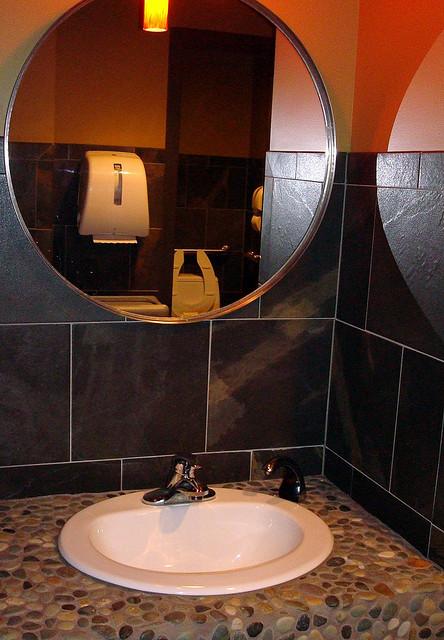Is the mirror above the sink round?
Give a very brief answer. Yes. Is there anyone using the toilet at this time?
Be succinct. No. Is the toilet seat up or down?
Keep it brief. Up. 